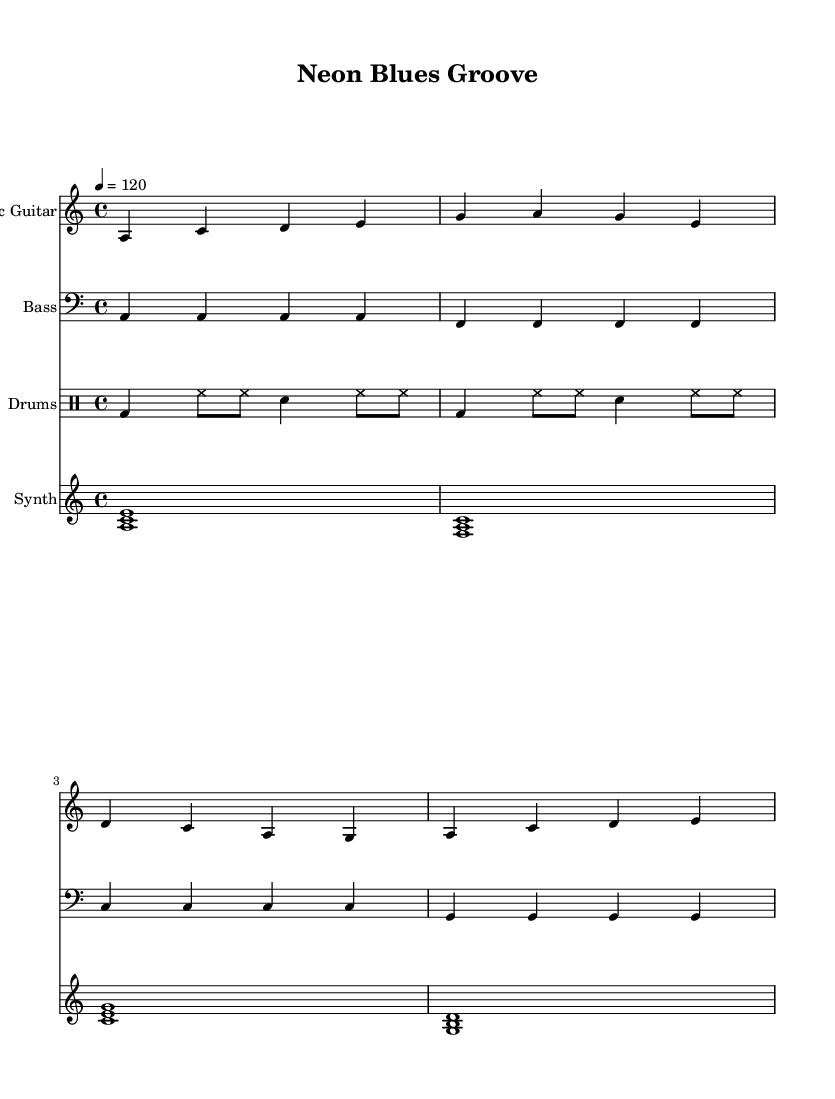What is the key signature of this music? The key signature shows one flat, indicating that it is in A minor. A minor is the relative minor to C major, which has no sharps or flats.
Answer: A minor What is the time signature of the piece? The time signature is indicated at the beginning of the sheet music as a 4 over 4, which means there are four beats in a measure and the quarter note gets one beat.
Answer: 4/4 What is the tempo marking of this composition? The tempo marking is located at the beginning of the score, indicated by the beat specification "4 = 120," meaning there are 120 beats per minute.
Answer: 120 Which instrument is playing the lead melody? The Electric Guitar part is shown on the top staff and contains the main melodic lines that define the character of the piece.
Answer: Electric Guitar How many measures does the electric guitar part consist of in the score? Counting the distinct sections based on the dividing bar lines, the electric guitar part contains four measures. Each measure is separated by a vertical line.
Answer: 4 What is the role of the synth pad in this piece? The synth pad uses chords created by clusters of notes that provide a harmonic background, enhancing the overall atmosphere and support for the melody. It does not play the main melody but complements it.
Answer: Harmonic background What style influences are reflected in the rhythmic pattern of the drums? The drum part utilizes a consistent bass drum and hi-hat pattern, typical of modern dance music, while incorporating backbeats with snare hits that align with blues conventions, emphasizing the fusion of genres.
Answer: Fusion of genres 